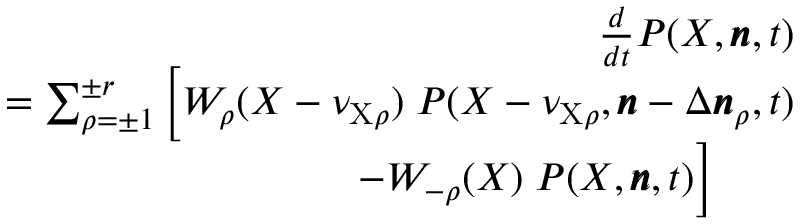<formula> <loc_0><loc_0><loc_500><loc_500>\begin{array} { r l r } & { \frac { d } { d t } P ( X , \pm b { n } , t ) } \\ & { = \sum _ { \rho = \pm 1 } ^ { \pm r } \left [ W _ { \rho } ( X - \nu _ { X \rho } ) \, P ( X - \nu _ { X \rho } , \pm b { n } - \Delta \pm b { n } _ { \rho } , t ) } \\ & { \quad - W _ { - \rho } ( X ) \, P ( X , \pm b { n } , t ) \right ] \quad } \end{array}</formula> 